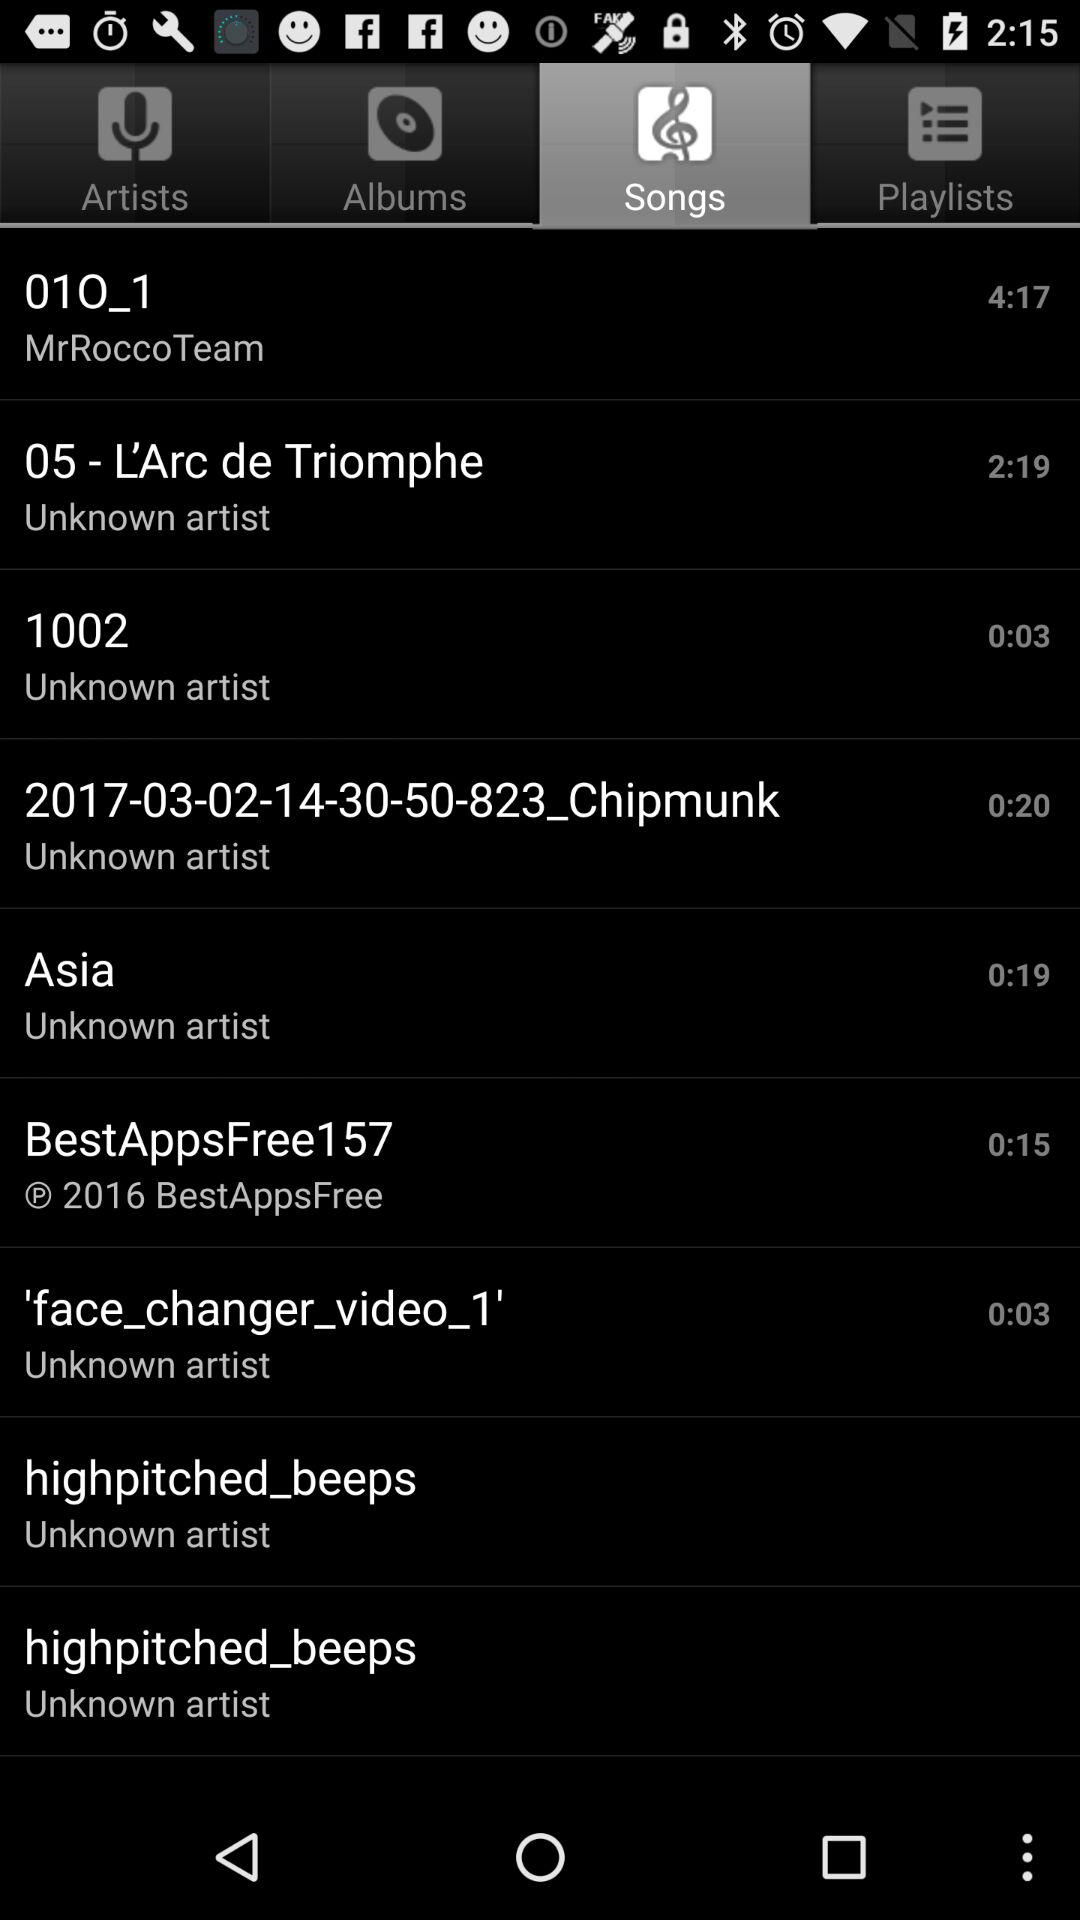Who wrote the song "01O_1"? The song was written by MrRocccoTeam. 